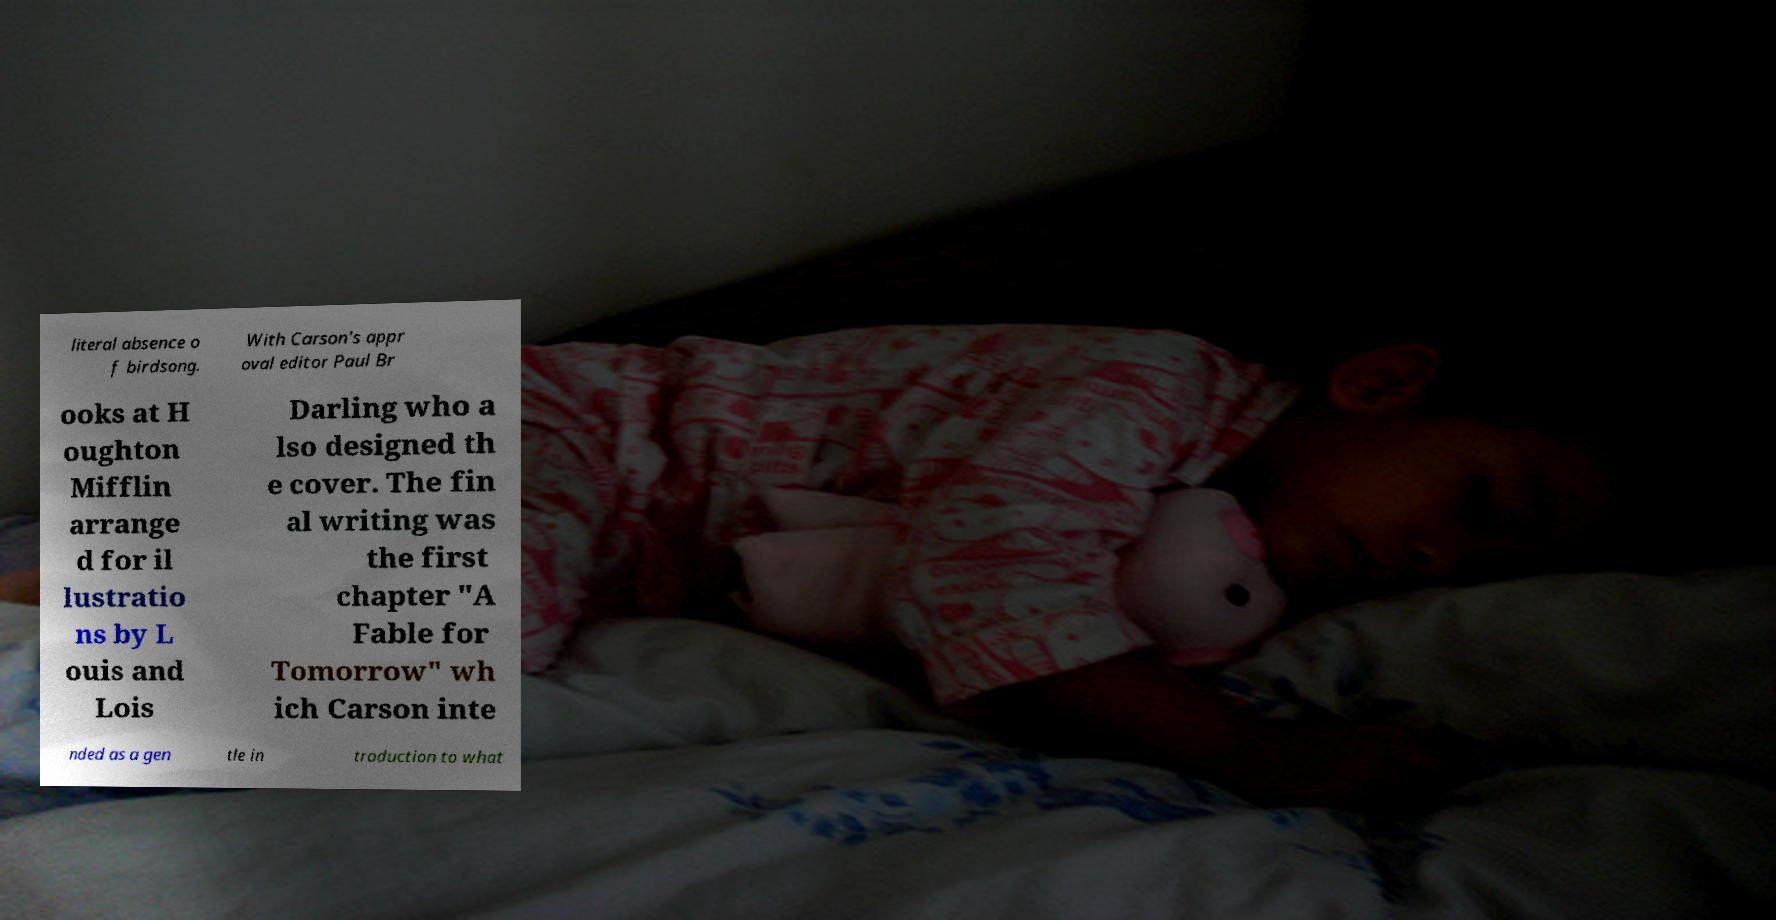Can you read and provide the text displayed in the image?This photo seems to have some interesting text. Can you extract and type it out for me? literal absence o f birdsong. With Carson's appr oval editor Paul Br ooks at H oughton Mifflin arrange d for il lustratio ns by L ouis and Lois Darling who a lso designed th e cover. The fin al writing was the first chapter "A Fable for Tomorrow" wh ich Carson inte nded as a gen tle in troduction to what 